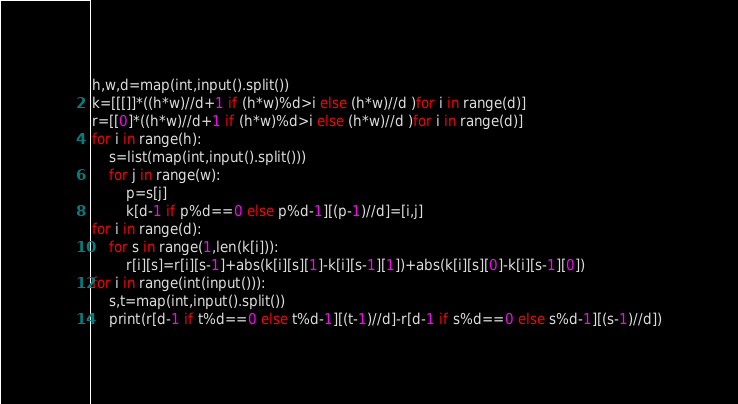<code> <loc_0><loc_0><loc_500><loc_500><_Python_>h,w,d=map(int,input().split())
k=[[[]]*((h*w)//d+1 if (h*w)%d>i else (h*w)//d )for i in range(d)]
r=[[0]*((h*w)//d+1 if (h*w)%d>i else (h*w)//d )for i in range(d)]
for i in range(h):
    s=list(map(int,input().split()))
    for j in range(w):
        p=s[j]
        k[d-1 if p%d==0 else p%d-1][(p-1)//d]=[i,j]
for i in range(d):
    for s in range(1,len(k[i])):
        r[i][s]=r[i][s-1]+abs(k[i][s][1]-k[i][s-1][1])+abs(k[i][s][0]-k[i][s-1][0])
for i in range(int(input())):
    s,t=map(int,input().split())
    print(r[d-1 if t%d==0 else t%d-1][(t-1)//d]-r[d-1 if s%d==0 else s%d-1][(s-1)//d])</code> 